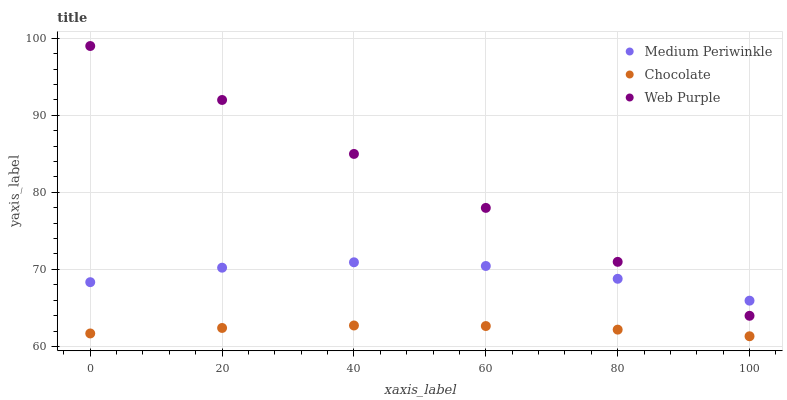Does Chocolate have the minimum area under the curve?
Answer yes or no. Yes. Does Web Purple have the maximum area under the curve?
Answer yes or no. Yes. Does Medium Periwinkle have the minimum area under the curve?
Answer yes or no. No. Does Medium Periwinkle have the maximum area under the curve?
Answer yes or no. No. Is Web Purple the smoothest?
Answer yes or no. Yes. Is Medium Periwinkle the roughest?
Answer yes or no. Yes. Is Chocolate the smoothest?
Answer yes or no. No. Is Chocolate the roughest?
Answer yes or no. No. Does Chocolate have the lowest value?
Answer yes or no. Yes. Does Medium Periwinkle have the lowest value?
Answer yes or no. No. Does Web Purple have the highest value?
Answer yes or no. Yes. Does Medium Periwinkle have the highest value?
Answer yes or no. No. Is Chocolate less than Medium Periwinkle?
Answer yes or no. Yes. Is Medium Periwinkle greater than Chocolate?
Answer yes or no. Yes. Does Medium Periwinkle intersect Web Purple?
Answer yes or no. Yes. Is Medium Periwinkle less than Web Purple?
Answer yes or no. No. Is Medium Periwinkle greater than Web Purple?
Answer yes or no. No. Does Chocolate intersect Medium Periwinkle?
Answer yes or no. No. 